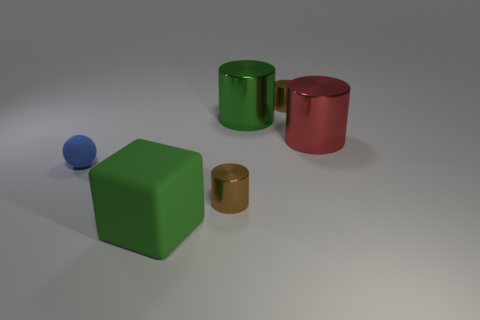What number of purple matte cylinders are there?
Offer a very short reply. 0. How many objects are green cylinders or small brown cylinders behind the green cylinder?
Provide a short and direct response. 2. Is there any other thing that is the same shape as the green metallic object?
Make the answer very short. Yes. Does the rubber object behind the green matte thing have the same size as the big red metal cylinder?
Your answer should be very brief. No. What number of shiny objects are either small blue spheres or small green cylinders?
Your answer should be very brief. 0. There is a green object to the right of the big matte object; how big is it?
Ensure brevity in your answer.  Large. Is the shape of the small matte thing the same as the large red shiny thing?
Give a very brief answer. No. How many small things are either balls or yellow cubes?
Your answer should be compact. 1. Are there any red metal objects behind the big red thing?
Offer a terse response. No. Is the number of tiny blue matte things that are in front of the green matte block the same as the number of small purple matte objects?
Your response must be concise. Yes. 